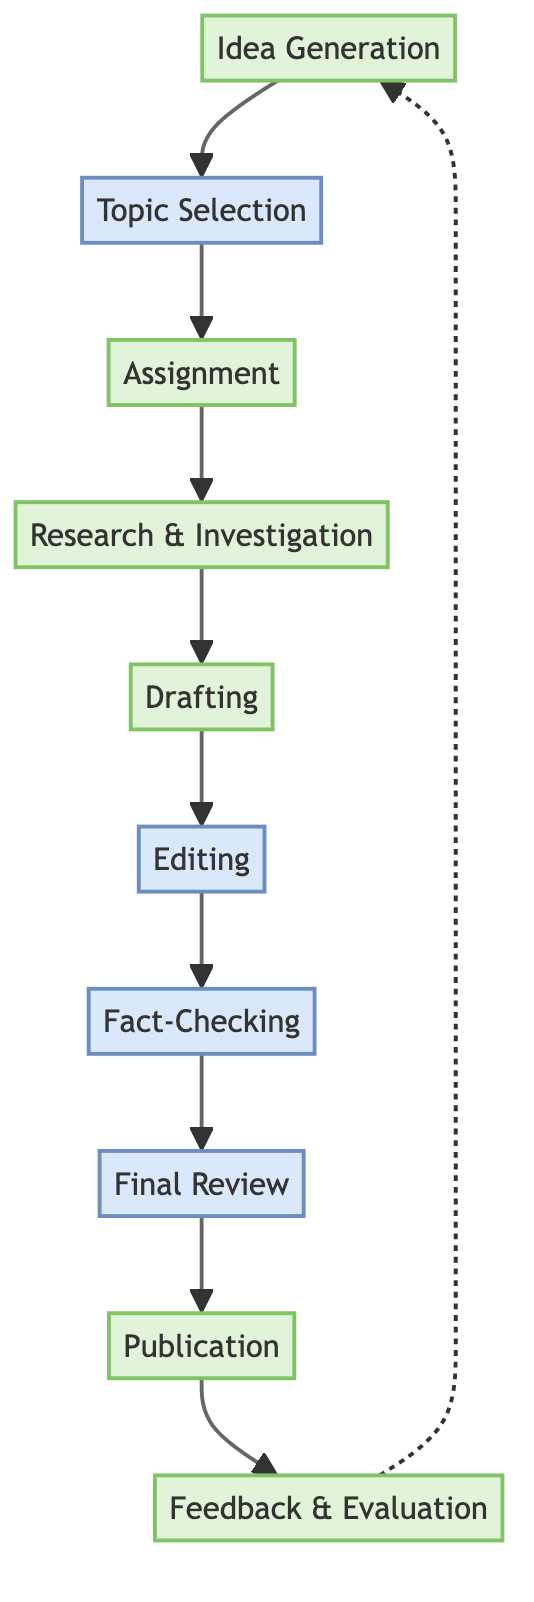What is the first step in the editorial decision-making process? The first step in the flow chart is "Idea Generation," indicating where initial ideas for stories are brainstormed.
Answer: Idea Generation How many steps are in the editorial decision-making process? The flow chart contains ten distinct steps, ranging from "Idea Generation" to "Feedback & Evaluation."
Answer: 10 Which department is involved in the "Final Review" step? The "Final Review" step involves "Senior Editors" and the "Editorial Board."
Answer: Senior Editors, Editorial Board What is the purpose of the "Fact-Checking" step in the diagram? "Fact-Checking" is specifically for verifying facts, figures, and quotations used in the article by a dedicated team.
Answer: Verify facts What step comes after "Editing"? The step that follows "Editing" is "Fact-Checking," as shown by the flow direction in the diagram.
Answer: Fact-Checking What two departments are responsible for "Research & Investigation"? The departments involved are "Investigative Team" and "Data Journalists," as indicated in the description of the "Research & Investigation" node.
Answer: Investigative Team, Data Journalists How does the process continue after "Publication"? After "Publication," the flow continues to "Feedback & Evaluation," which indicates a cyclical nature where feedback is collected and evaluated post-publication.
Answer: Feedback & Evaluation What type of question is answered through the "Feedback & Evaluation" step? The "Feedback & Evaluation" step collects and analyzes post-publication feedback from readers and stakeholders, indicating its purpose in audience engagement.
Answer: Audience engagement What is needed before an article can be published? Before publication, the article must go through the "Final Review" where it receives approval from senior editors or the editorial board.
Answer: Final Review approval Which step involves assigning topics to reporters? The "Assignment" step is where chosen topics are assigned to specific reporters or journalists, highlighting its role in the process.
Answer: Assignment 